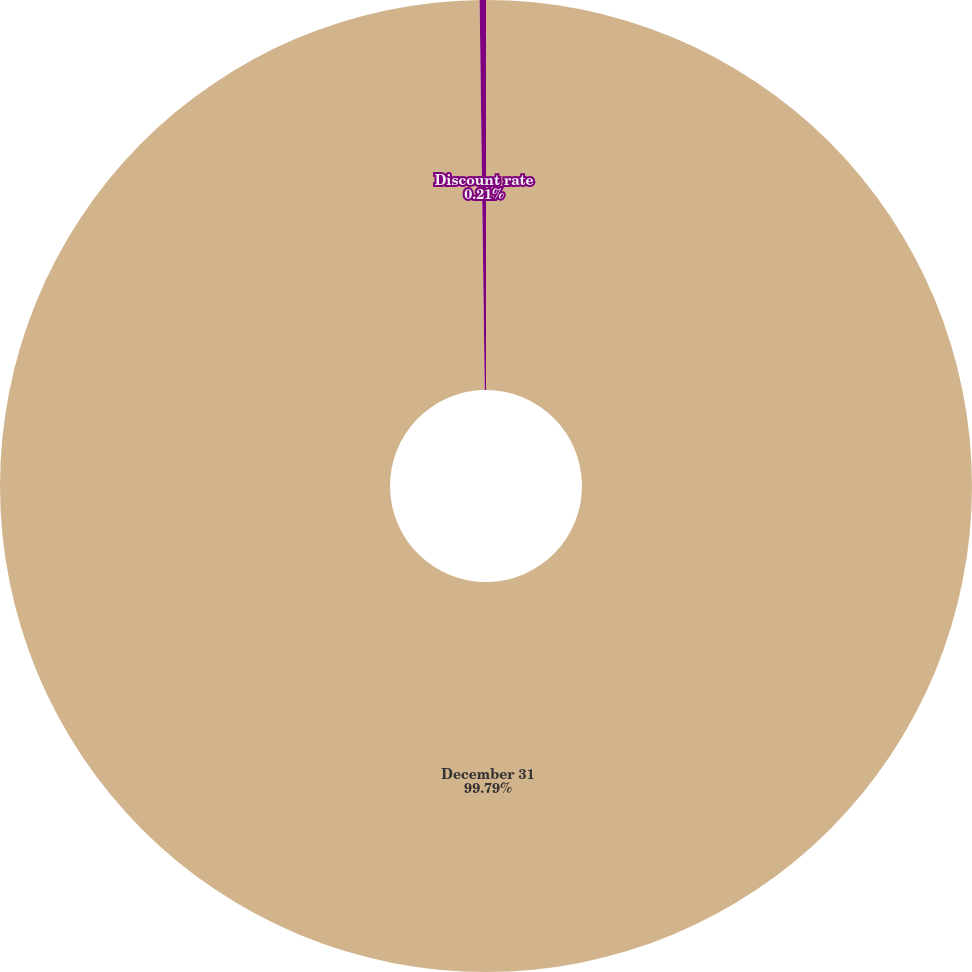Convert chart. <chart><loc_0><loc_0><loc_500><loc_500><pie_chart><fcel>December 31<fcel>Discount rate<nl><fcel>99.79%<fcel>0.21%<nl></chart> 